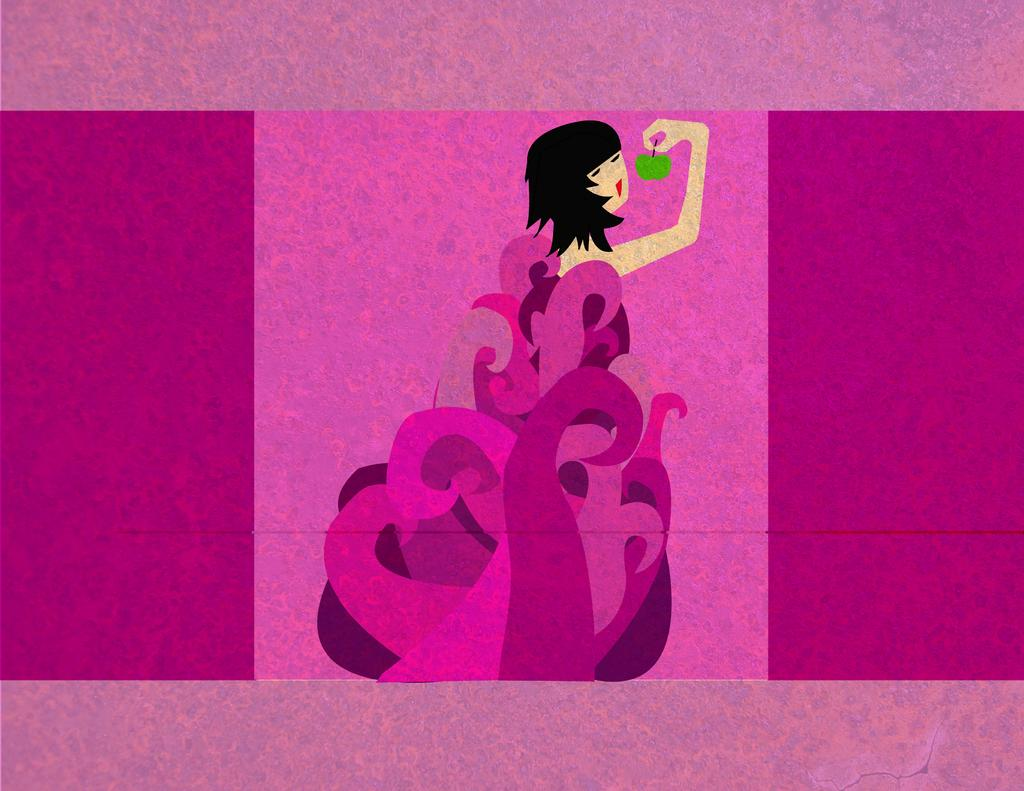What is the main subject of the painting? The painting depicts a woman. What is the woman wearing in the painting? The woman is wearing a pink dress in the painting. What object is the woman holding in the painting? The woman is holding a green apple in her hand in the painting. What advice does the woman's father give her in the painting? There is no father present in the painting, nor is there any dialogue or advice being given. 